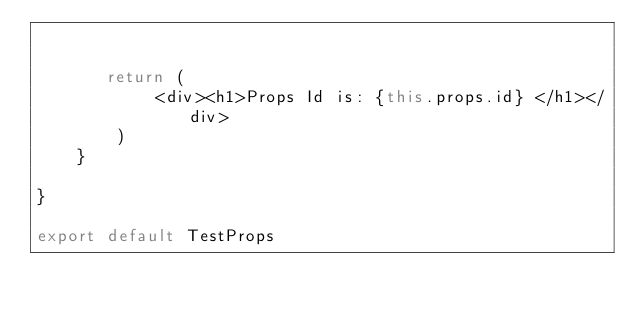Convert code to text. <code><loc_0><loc_0><loc_500><loc_500><_JavaScript_>    
        
       return (
            <div><h1>Props Id is: {this.props.id} </h1></div>
        )
    }

}

export default TestProps




</code> 